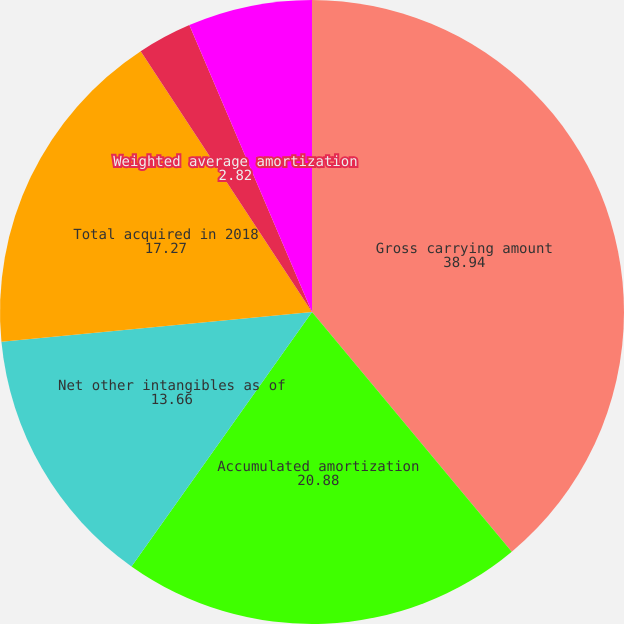Convert chart. <chart><loc_0><loc_0><loc_500><loc_500><pie_chart><fcel>Gross carrying amount<fcel>Accumulated amortization<fcel>Net other intangibles as of<fcel>Total acquired in 2018<fcel>Weighted average amortization<fcel>Total acquired in 2017<nl><fcel>38.94%<fcel>20.88%<fcel>13.66%<fcel>17.27%<fcel>2.82%<fcel>6.43%<nl></chart> 